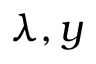<formula> <loc_0><loc_0><loc_500><loc_500>\lambda , y</formula> 